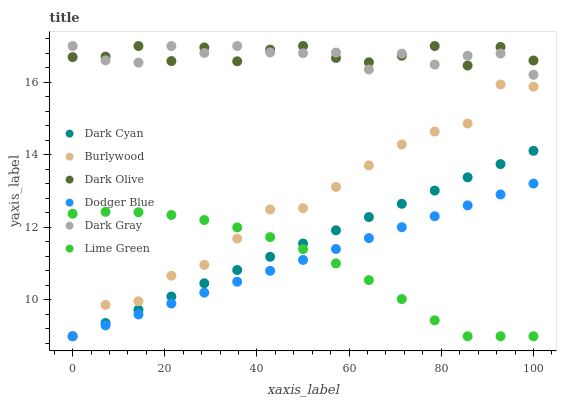Does Lime Green have the minimum area under the curve?
Answer yes or no. Yes. Does Dark Olive have the maximum area under the curve?
Answer yes or no. Yes. Does Dark Gray have the minimum area under the curve?
Answer yes or no. No. Does Dark Gray have the maximum area under the curve?
Answer yes or no. No. Is Dodger Blue the smoothest?
Answer yes or no. Yes. Is Dark Olive the roughest?
Answer yes or no. Yes. Is Dark Gray the smoothest?
Answer yes or no. No. Is Dark Gray the roughest?
Answer yes or no. No. Does Burlywood have the lowest value?
Answer yes or no. Yes. Does Dark Gray have the lowest value?
Answer yes or no. No. Does Dark Gray have the highest value?
Answer yes or no. Yes. Does Dodger Blue have the highest value?
Answer yes or no. No. Is Dark Cyan less than Dark Olive?
Answer yes or no. Yes. Is Dark Gray greater than Dodger Blue?
Answer yes or no. Yes. Does Dark Cyan intersect Dodger Blue?
Answer yes or no. Yes. Is Dark Cyan less than Dodger Blue?
Answer yes or no. No. Is Dark Cyan greater than Dodger Blue?
Answer yes or no. No. Does Dark Cyan intersect Dark Olive?
Answer yes or no. No. 